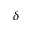<formula> <loc_0><loc_0><loc_500><loc_500>\delta</formula> 